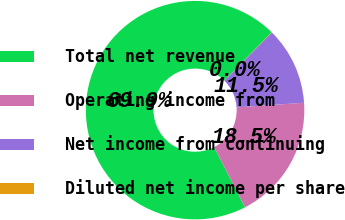<chart> <loc_0><loc_0><loc_500><loc_500><pie_chart><fcel>Total net revenue<fcel>Operating income from<fcel>Net income from continuing<fcel>Diluted net income per share<nl><fcel>69.94%<fcel>18.51%<fcel>11.51%<fcel>0.04%<nl></chart> 